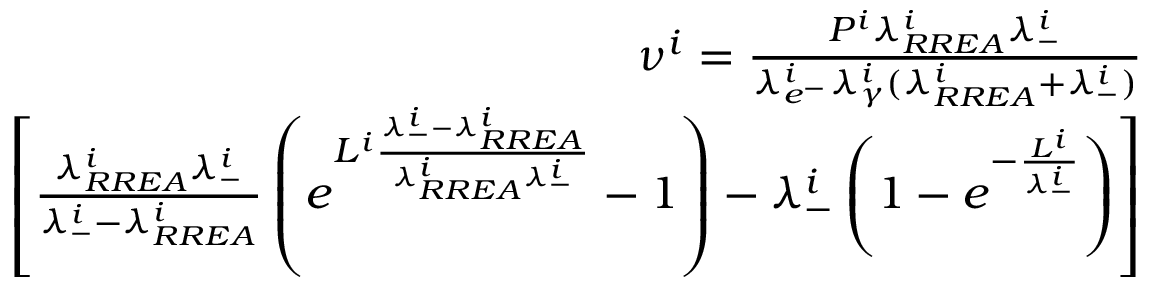Convert formula to latex. <formula><loc_0><loc_0><loc_500><loc_500>\begin{array} { r } { \nu ^ { i } = \frac { P ^ { i } \lambda _ { R R E A } ^ { i } \lambda _ { - } ^ { i } } { \lambda _ { e ^ { - } } ^ { i } \lambda _ { \gamma } ^ { i } ( \lambda _ { R R E A } ^ { i } + \lambda _ { - } ^ { i } ) } } \\ { \left [ \frac { \lambda _ { R R E A } ^ { i } \lambda _ { - } ^ { i } } { \lambda _ { - } ^ { i } - \lambda _ { R R E A } ^ { i } } \left ( e ^ { L ^ { i } \frac { \lambda _ { - } ^ { i } - \lambda _ { R R E A } ^ { i } } { \lambda _ { R R E A } ^ { i } \lambda _ { - } ^ { i } } } - 1 \right ) - \lambda _ { - } ^ { i } \left ( 1 - e ^ { - \frac { L ^ { i } } { \lambda _ { - } ^ { i } } } \right ) \right ] } \end{array}</formula> 